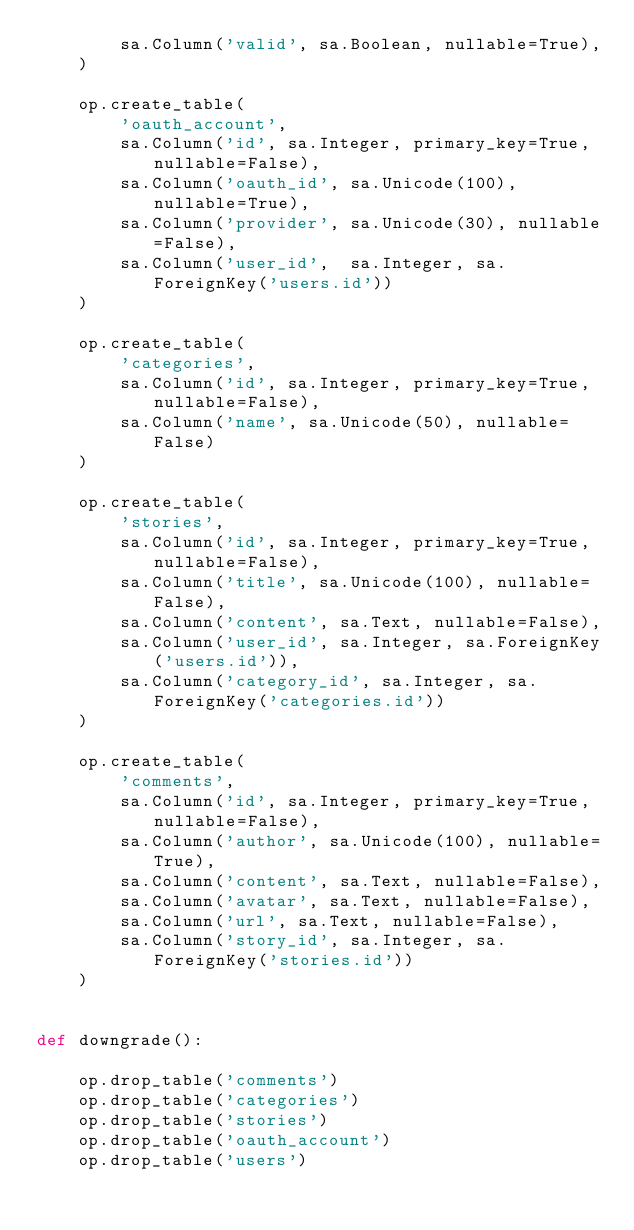Convert code to text. <code><loc_0><loc_0><loc_500><loc_500><_Python_>        sa.Column('valid', sa.Boolean, nullable=True),
    )

    op.create_table(
        'oauth_account',
        sa.Column('id', sa.Integer, primary_key=True, nullable=False),
        sa.Column('oauth_id', sa.Unicode(100), nullable=True),
        sa.Column('provider', sa.Unicode(30), nullable=False),
        sa.Column('user_id',  sa.Integer, sa.ForeignKey('users.id'))
    )

    op.create_table(
        'categories',
        sa.Column('id', sa.Integer, primary_key=True, nullable=False),
        sa.Column('name', sa.Unicode(50), nullable=False)
    )
              
    op.create_table(
        'stories',
        sa.Column('id', sa.Integer, primary_key=True, nullable=False),
        sa.Column('title', sa.Unicode(100), nullable=False),
        sa.Column('content', sa.Text, nullable=False),
        sa.Column('user_id', sa.Integer, sa.ForeignKey('users.id')),
        sa.Column('category_id', sa.Integer, sa.ForeignKey('categories.id'))
    )
 
    op.create_table(
        'comments',
        sa.Column('id', sa.Integer, primary_key=True, nullable=False),
        sa.Column('author', sa.Unicode(100), nullable=True),
        sa.Column('content', sa.Text, nullable=False),
        sa.Column('avatar', sa.Text, nullable=False),
        sa.Column('url', sa.Text, nullable=False),
        sa.Column('story_id', sa.Integer, sa.ForeignKey('stories.id'))
    )


def downgrade():

    op.drop_table('comments')
    op.drop_table('categories')
    op.drop_table('stories')
    op.drop_table('oauth_account')
    op.drop_table('users')




</code> 